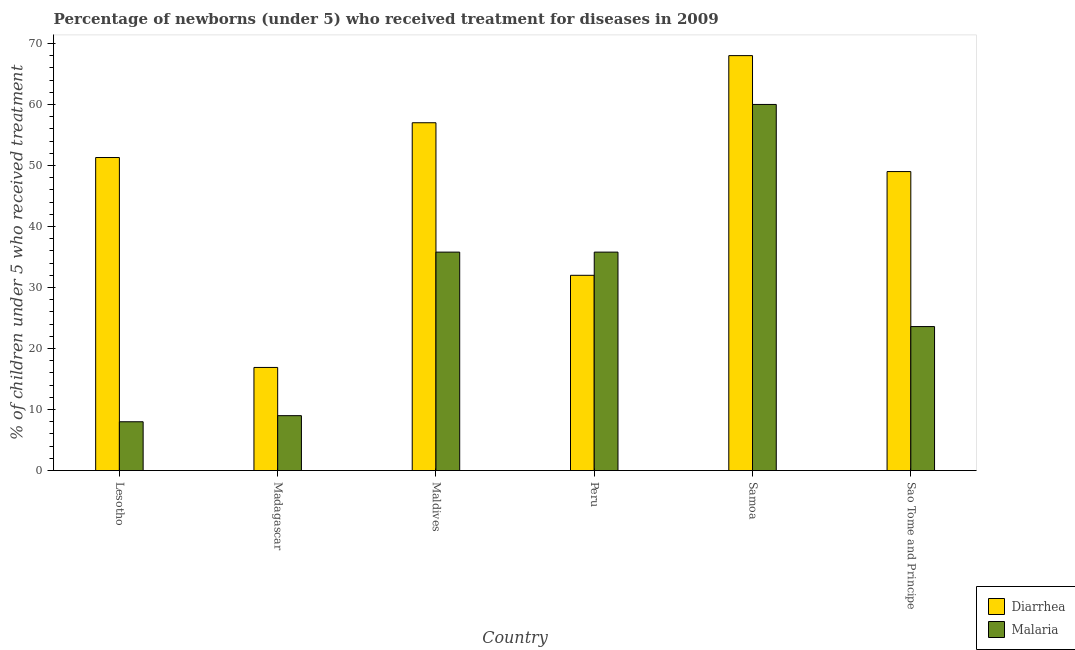How many different coloured bars are there?
Your answer should be very brief. 2. How many groups of bars are there?
Give a very brief answer. 6. Are the number of bars on each tick of the X-axis equal?
Provide a succinct answer. Yes. How many bars are there on the 5th tick from the left?
Offer a very short reply. 2. How many bars are there on the 1st tick from the right?
Offer a very short reply. 2. What is the label of the 3rd group of bars from the left?
Make the answer very short. Maldives. In how many cases, is the number of bars for a given country not equal to the number of legend labels?
Keep it short and to the point. 0. What is the percentage of children who received treatment for malaria in Peru?
Give a very brief answer. 35.8. Across all countries, what is the maximum percentage of children who received treatment for malaria?
Your answer should be very brief. 60. Across all countries, what is the minimum percentage of children who received treatment for diarrhoea?
Offer a very short reply. 16.9. In which country was the percentage of children who received treatment for diarrhoea maximum?
Make the answer very short. Samoa. In which country was the percentage of children who received treatment for malaria minimum?
Offer a terse response. Lesotho. What is the total percentage of children who received treatment for diarrhoea in the graph?
Make the answer very short. 274.2. What is the difference between the percentage of children who received treatment for malaria in Lesotho and that in Maldives?
Ensure brevity in your answer.  -27.8. What is the average percentage of children who received treatment for malaria per country?
Offer a very short reply. 28.7. What is the difference between the percentage of children who received treatment for malaria and percentage of children who received treatment for diarrhoea in Sao Tome and Principe?
Your answer should be compact. -25.4. In how many countries, is the percentage of children who received treatment for malaria greater than 16 %?
Keep it short and to the point. 4. What is the ratio of the percentage of children who received treatment for malaria in Samoa to that in Sao Tome and Principe?
Your answer should be very brief. 2.54. Is the percentage of children who received treatment for malaria in Maldives less than that in Samoa?
Offer a very short reply. Yes. What is the difference between the highest and the second highest percentage of children who received treatment for diarrhoea?
Keep it short and to the point. 11. What is the difference between the highest and the lowest percentage of children who received treatment for diarrhoea?
Your answer should be very brief. 51.1. In how many countries, is the percentage of children who received treatment for malaria greater than the average percentage of children who received treatment for malaria taken over all countries?
Your answer should be compact. 3. Is the sum of the percentage of children who received treatment for diarrhoea in Madagascar and Peru greater than the maximum percentage of children who received treatment for malaria across all countries?
Your answer should be very brief. No. What does the 1st bar from the left in Maldives represents?
Provide a succinct answer. Diarrhea. What does the 2nd bar from the right in Madagascar represents?
Keep it short and to the point. Diarrhea. Are all the bars in the graph horizontal?
Give a very brief answer. No. What is the difference between two consecutive major ticks on the Y-axis?
Offer a very short reply. 10. How many legend labels are there?
Offer a very short reply. 2. What is the title of the graph?
Your response must be concise. Percentage of newborns (under 5) who received treatment for diseases in 2009. Does "Current education expenditure" appear as one of the legend labels in the graph?
Keep it short and to the point. No. What is the label or title of the X-axis?
Your answer should be very brief. Country. What is the label or title of the Y-axis?
Your answer should be compact. % of children under 5 who received treatment. What is the % of children under 5 who received treatment in Diarrhea in Lesotho?
Offer a very short reply. 51.3. What is the % of children under 5 who received treatment in Diarrhea in Madagascar?
Give a very brief answer. 16.9. What is the % of children under 5 who received treatment in Diarrhea in Maldives?
Your answer should be compact. 57. What is the % of children under 5 who received treatment in Malaria in Maldives?
Make the answer very short. 35.8. What is the % of children under 5 who received treatment of Diarrhea in Peru?
Offer a terse response. 32. What is the % of children under 5 who received treatment of Malaria in Peru?
Offer a terse response. 35.8. What is the % of children under 5 who received treatment of Diarrhea in Samoa?
Your answer should be compact. 68. What is the % of children under 5 who received treatment of Diarrhea in Sao Tome and Principe?
Provide a short and direct response. 49. What is the % of children under 5 who received treatment of Malaria in Sao Tome and Principe?
Give a very brief answer. 23.6. Across all countries, what is the maximum % of children under 5 who received treatment of Diarrhea?
Provide a succinct answer. 68. Across all countries, what is the maximum % of children under 5 who received treatment in Malaria?
Provide a succinct answer. 60. Across all countries, what is the minimum % of children under 5 who received treatment in Malaria?
Give a very brief answer. 8. What is the total % of children under 5 who received treatment in Diarrhea in the graph?
Keep it short and to the point. 274.2. What is the total % of children under 5 who received treatment in Malaria in the graph?
Keep it short and to the point. 172.2. What is the difference between the % of children under 5 who received treatment of Diarrhea in Lesotho and that in Madagascar?
Offer a terse response. 34.4. What is the difference between the % of children under 5 who received treatment in Malaria in Lesotho and that in Madagascar?
Provide a short and direct response. -1. What is the difference between the % of children under 5 who received treatment of Malaria in Lesotho and that in Maldives?
Provide a succinct answer. -27.8. What is the difference between the % of children under 5 who received treatment in Diarrhea in Lesotho and that in Peru?
Offer a terse response. 19.3. What is the difference between the % of children under 5 who received treatment of Malaria in Lesotho and that in Peru?
Offer a very short reply. -27.8. What is the difference between the % of children under 5 who received treatment in Diarrhea in Lesotho and that in Samoa?
Keep it short and to the point. -16.7. What is the difference between the % of children under 5 who received treatment of Malaria in Lesotho and that in Samoa?
Make the answer very short. -52. What is the difference between the % of children under 5 who received treatment of Malaria in Lesotho and that in Sao Tome and Principe?
Your response must be concise. -15.6. What is the difference between the % of children under 5 who received treatment in Diarrhea in Madagascar and that in Maldives?
Provide a short and direct response. -40.1. What is the difference between the % of children under 5 who received treatment in Malaria in Madagascar and that in Maldives?
Your answer should be very brief. -26.8. What is the difference between the % of children under 5 who received treatment of Diarrhea in Madagascar and that in Peru?
Make the answer very short. -15.1. What is the difference between the % of children under 5 who received treatment in Malaria in Madagascar and that in Peru?
Keep it short and to the point. -26.8. What is the difference between the % of children under 5 who received treatment in Diarrhea in Madagascar and that in Samoa?
Ensure brevity in your answer.  -51.1. What is the difference between the % of children under 5 who received treatment in Malaria in Madagascar and that in Samoa?
Give a very brief answer. -51. What is the difference between the % of children under 5 who received treatment of Diarrhea in Madagascar and that in Sao Tome and Principe?
Provide a short and direct response. -32.1. What is the difference between the % of children under 5 who received treatment in Malaria in Madagascar and that in Sao Tome and Principe?
Offer a terse response. -14.6. What is the difference between the % of children under 5 who received treatment of Diarrhea in Maldives and that in Peru?
Provide a succinct answer. 25. What is the difference between the % of children under 5 who received treatment in Malaria in Maldives and that in Peru?
Offer a terse response. 0. What is the difference between the % of children under 5 who received treatment in Malaria in Maldives and that in Samoa?
Ensure brevity in your answer.  -24.2. What is the difference between the % of children under 5 who received treatment of Diarrhea in Peru and that in Samoa?
Give a very brief answer. -36. What is the difference between the % of children under 5 who received treatment of Malaria in Peru and that in Samoa?
Keep it short and to the point. -24.2. What is the difference between the % of children under 5 who received treatment of Malaria in Peru and that in Sao Tome and Principe?
Give a very brief answer. 12.2. What is the difference between the % of children under 5 who received treatment in Malaria in Samoa and that in Sao Tome and Principe?
Make the answer very short. 36.4. What is the difference between the % of children under 5 who received treatment of Diarrhea in Lesotho and the % of children under 5 who received treatment of Malaria in Madagascar?
Your answer should be very brief. 42.3. What is the difference between the % of children under 5 who received treatment of Diarrhea in Lesotho and the % of children under 5 who received treatment of Malaria in Peru?
Your answer should be very brief. 15.5. What is the difference between the % of children under 5 who received treatment in Diarrhea in Lesotho and the % of children under 5 who received treatment in Malaria in Sao Tome and Principe?
Provide a succinct answer. 27.7. What is the difference between the % of children under 5 who received treatment in Diarrhea in Madagascar and the % of children under 5 who received treatment in Malaria in Maldives?
Your response must be concise. -18.9. What is the difference between the % of children under 5 who received treatment of Diarrhea in Madagascar and the % of children under 5 who received treatment of Malaria in Peru?
Offer a terse response. -18.9. What is the difference between the % of children under 5 who received treatment of Diarrhea in Madagascar and the % of children under 5 who received treatment of Malaria in Samoa?
Ensure brevity in your answer.  -43.1. What is the difference between the % of children under 5 who received treatment of Diarrhea in Madagascar and the % of children under 5 who received treatment of Malaria in Sao Tome and Principe?
Your answer should be very brief. -6.7. What is the difference between the % of children under 5 who received treatment in Diarrhea in Maldives and the % of children under 5 who received treatment in Malaria in Peru?
Your answer should be compact. 21.2. What is the difference between the % of children under 5 who received treatment of Diarrhea in Maldives and the % of children under 5 who received treatment of Malaria in Samoa?
Make the answer very short. -3. What is the difference between the % of children under 5 who received treatment of Diarrhea in Maldives and the % of children under 5 who received treatment of Malaria in Sao Tome and Principe?
Your response must be concise. 33.4. What is the difference between the % of children under 5 who received treatment in Diarrhea in Peru and the % of children under 5 who received treatment in Malaria in Samoa?
Give a very brief answer. -28. What is the difference between the % of children under 5 who received treatment of Diarrhea in Peru and the % of children under 5 who received treatment of Malaria in Sao Tome and Principe?
Provide a short and direct response. 8.4. What is the difference between the % of children under 5 who received treatment in Diarrhea in Samoa and the % of children under 5 who received treatment in Malaria in Sao Tome and Principe?
Your response must be concise. 44.4. What is the average % of children under 5 who received treatment in Diarrhea per country?
Provide a short and direct response. 45.7. What is the average % of children under 5 who received treatment of Malaria per country?
Offer a very short reply. 28.7. What is the difference between the % of children under 5 who received treatment of Diarrhea and % of children under 5 who received treatment of Malaria in Lesotho?
Ensure brevity in your answer.  43.3. What is the difference between the % of children under 5 who received treatment in Diarrhea and % of children under 5 who received treatment in Malaria in Maldives?
Keep it short and to the point. 21.2. What is the difference between the % of children under 5 who received treatment of Diarrhea and % of children under 5 who received treatment of Malaria in Samoa?
Give a very brief answer. 8. What is the difference between the % of children under 5 who received treatment in Diarrhea and % of children under 5 who received treatment in Malaria in Sao Tome and Principe?
Your response must be concise. 25.4. What is the ratio of the % of children under 5 who received treatment of Diarrhea in Lesotho to that in Madagascar?
Give a very brief answer. 3.04. What is the ratio of the % of children under 5 who received treatment in Malaria in Lesotho to that in Madagascar?
Offer a terse response. 0.89. What is the ratio of the % of children under 5 who received treatment of Malaria in Lesotho to that in Maldives?
Provide a succinct answer. 0.22. What is the ratio of the % of children under 5 who received treatment in Diarrhea in Lesotho to that in Peru?
Your answer should be very brief. 1.6. What is the ratio of the % of children under 5 who received treatment of Malaria in Lesotho to that in Peru?
Offer a terse response. 0.22. What is the ratio of the % of children under 5 who received treatment in Diarrhea in Lesotho to that in Samoa?
Provide a succinct answer. 0.75. What is the ratio of the % of children under 5 who received treatment in Malaria in Lesotho to that in Samoa?
Provide a succinct answer. 0.13. What is the ratio of the % of children under 5 who received treatment of Diarrhea in Lesotho to that in Sao Tome and Principe?
Provide a succinct answer. 1.05. What is the ratio of the % of children under 5 who received treatment of Malaria in Lesotho to that in Sao Tome and Principe?
Keep it short and to the point. 0.34. What is the ratio of the % of children under 5 who received treatment of Diarrhea in Madagascar to that in Maldives?
Keep it short and to the point. 0.3. What is the ratio of the % of children under 5 who received treatment in Malaria in Madagascar to that in Maldives?
Ensure brevity in your answer.  0.25. What is the ratio of the % of children under 5 who received treatment in Diarrhea in Madagascar to that in Peru?
Make the answer very short. 0.53. What is the ratio of the % of children under 5 who received treatment of Malaria in Madagascar to that in Peru?
Provide a succinct answer. 0.25. What is the ratio of the % of children under 5 who received treatment in Diarrhea in Madagascar to that in Samoa?
Make the answer very short. 0.25. What is the ratio of the % of children under 5 who received treatment of Malaria in Madagascar to that in Samoa?
Make the answer very short. 0.15. What is the ratio of the % of children under 5 who received treatment of Diarrhea in Madagascar to that in Sao Tome and Principe?
Offer a very short reply. 0.34. What is the ratio of the % of children under 5 who received treatment in Malaria in Madagascar to that in Sao Tome and Principe?
Your answer should be very brief. 0.38. What is the ratio of the % of children under 5 who received treatment in Diarrhea in Maldives to that in Peru?
Keep it short and to the point. 1.78. What is the ratio of the % of children under 5 who received treatment in Diarrhea in Maldives to that in Samoa?
Ensure brevity in your answer.  0.84. What is the ratio of the % of children under 5 who received treatment of Malaria in Maldives to that in Samoa?
Provide a succinct answer. 0.6. What is the ratio of the % of children under 5 who received treatment of Diarrhea in Maldives to that in Sao Tome and Principe?
Ensure brevity in your answer.  1.16. What is the ratio of the % of children under 5 who received treatment of Malaria in Maldives to that in Sao Tome and Principe?
Your response must be concise. 1.52. What is the ratio of the % of children under 5 who received treatment in Diarrhea in Peru to that in Samoa?
Give a very brief answer. 0.47. What is the ratio of the % of children under 5 who received treatment in Malaria in Peru to that in Samoa?
Ensure brevity in your answer.  0.6. What is the ratio of the % of children under 5 who received treatment in Diarrhea in Peru to that in Sao Tome and Principe?
Offer a terse response. 0.65. What is the ratio of the % of children under 5 who received treatment of Malaria in Peru to that in Sao Tome and Principe?
Provide a short and direct response. 1.52. What is the ratio of the % of children under 5 who received treatment in Diarrhea in Samoa to that in Sao Tome and Principe?
Give a very brief answer. 1.39. What is the ratio of the % of children under 5 who received treatment of Malaria in Samoa to that in Sao Tome and Principe?
Keep it short and to the point. 2.54. What is the difference between the highest and the second highest % of children under 5 who received treatment of Malaria?
Give a very brief answer. 24.2. What is the difference between the highest and the lowest % of children under 5 who received treatment of Diarrhea?
Your answer should be compact. 51.1. What is the difference between the highest and the lowest % of children under 5 who received treatment of Malaria?
Your answer should be very brief. 52. 